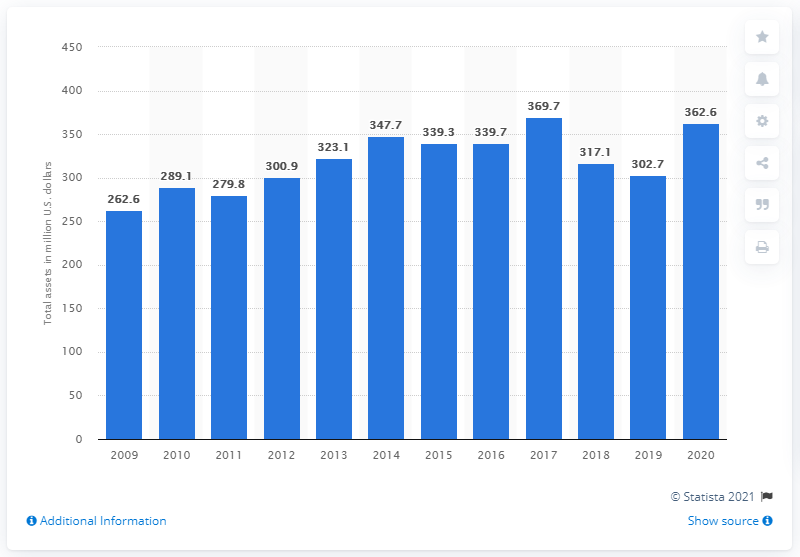Outline some significant characteristics in this image. In 2020, the total assets of WD-40 Company were 362.6 million dollars. 